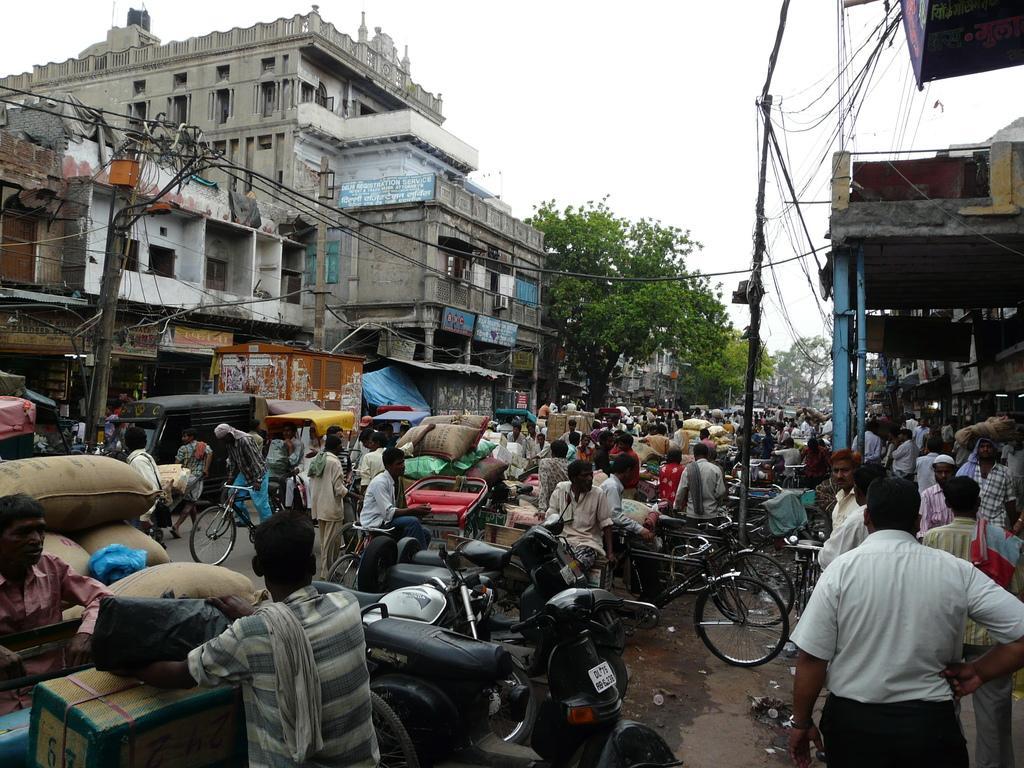Describe this image in one or two sentences. In the picture I can see the rickshaws on the road and rickshaws are loaded with luggage. I can see the motorcycles on the road. I can see a few persons on the road and I can see a group of people walking on the side of the road on the bottom right side. There are buildings on the left side and the right side as well. I can see the electric poles on both sides of the road. In the background, I can see the trees. There are clouds in the sky. 